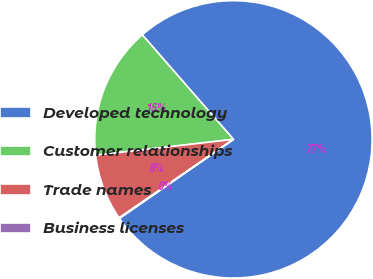Convert chart. <chart><loc_0><loc_0><loc_500><loc_500><pie_chart><fcel>Developed technology<fcel>Customer relationships<fcel>Trade names<fcel>Business licenses<nl><fcel>76.76%<fcel>15.41%<fcel>7.75%<fcel>0.08%<nl></chart> 